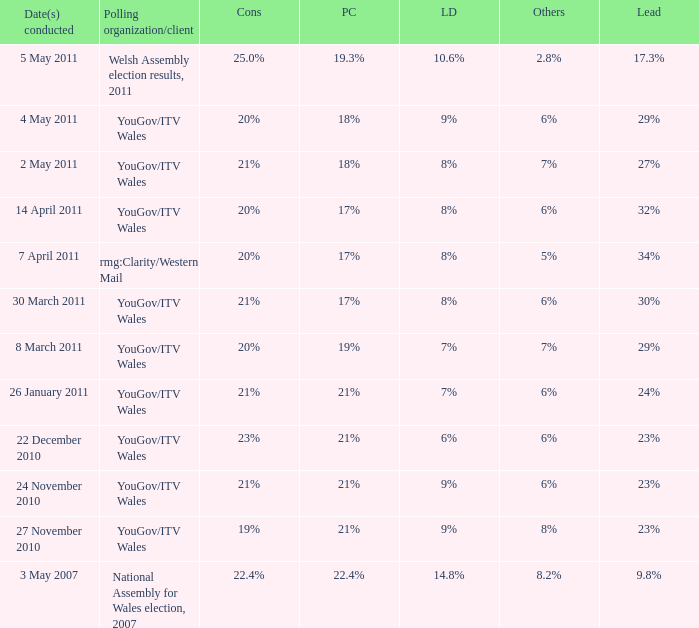I want the plaid cymru for Polling organisation/client of yougov/itv wales for 4 may 2011 18%. 